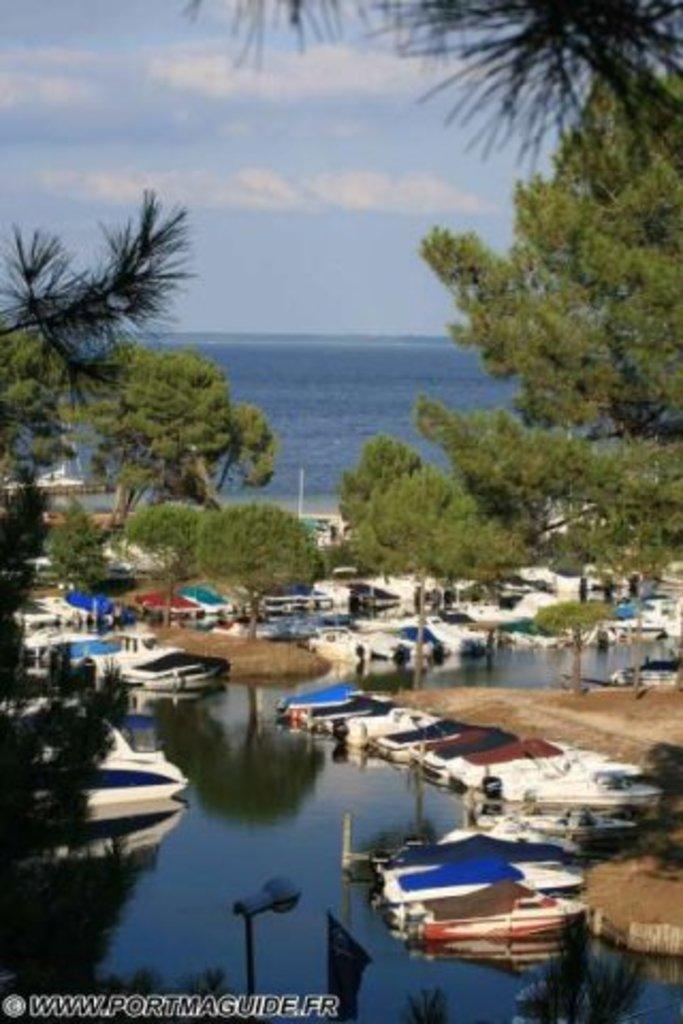In one or two sentences, can you explain what this image depicts? In this image in the center there is water and on the water there are boats. In the background there are trees and there is an ocean and the sky is cloudy. 